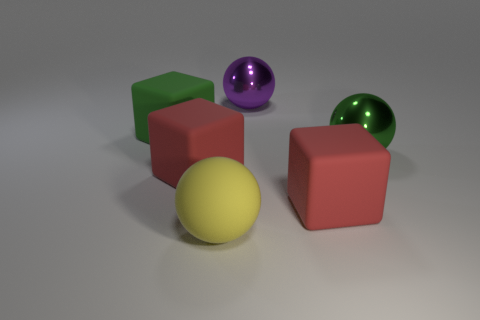The red matte thing that is right of the big metallic object behind the big green object in front of the green rubber cube is what shape?
Provide a short and direct response. Cube. What color is the matte cube right of the large purple metallic ball?
Ensure brevity in your answer.  Red. What number of objects are rubber things that are in front of the large green cube or large spheres on the right side of the purple ball?
Offer a terse response. 4. What number of large purple things have the same shape as the big green matte thing?
Provide a succinct answer. 0. What color is the shiny sphere that is the same size as the purple metallic thing?
Your answer should be compact. Green. There is a rubber block in front of the red thing to the left of the large matte thing that is right of the purple metal ball; what is its color?
Your answer should be very brief. Red. What number of objects are either purple things or big green matte things?
Offer a very short reply. 2. Is there another big green ball that has the same material as the big green ball?
Your answer should be compact. No. What is the color of the big thing in front of the block that is on the right side of the large purple object?
Offer a very short reply. Yellow. What number of cylinders are either metallic things or green things?
Keep it short and to the point. 0. 